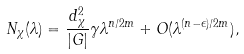<formula> <loc_0><loc_0><loc_500><loc_500>N _ { \chi } ( \lambda ) = \frac { d ^ { 2 } _ { \chi } } { | G | } \gamma \lambda ^ { n / 2 m } + O ( \lambda ^ { ( n - \epsilon ) / 2 m } ) ,</formula> 